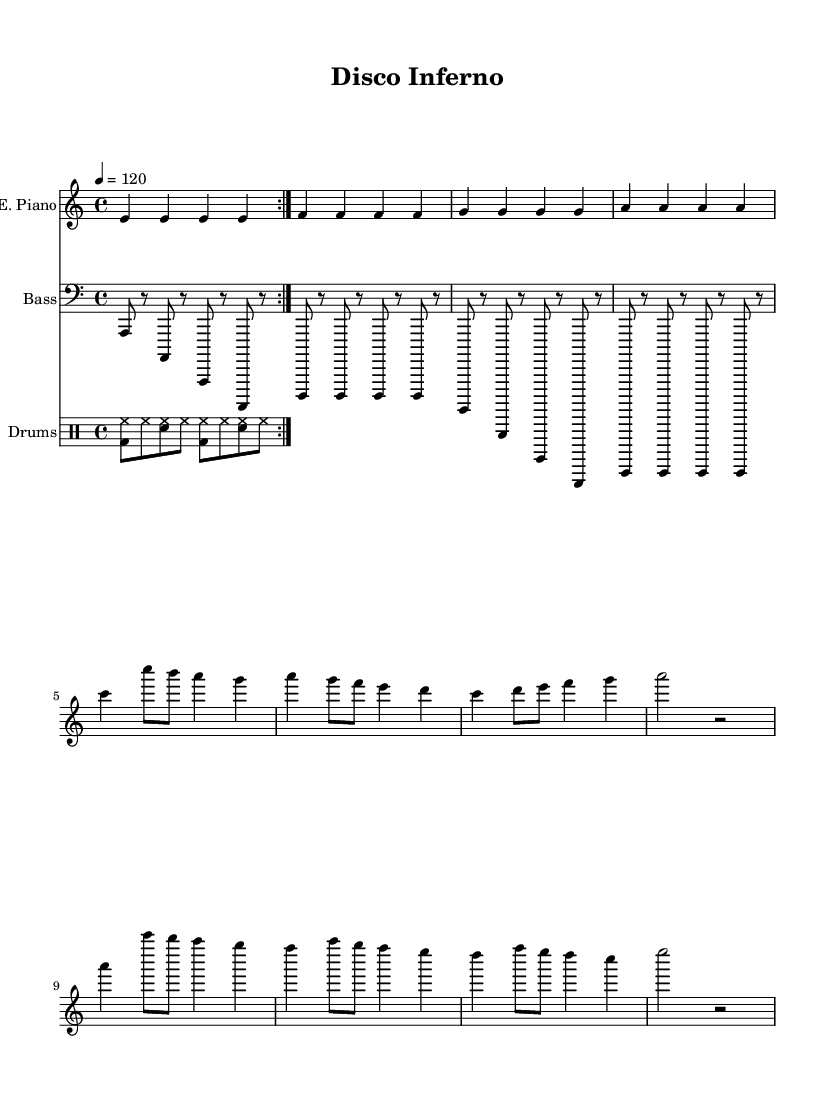What is the key signature of this music? The key signature is A minor, which has no sharps or flats. This can be determined by looking at the key signature indication at the beginning of the staff, which shows no accidentals.
Answer: A minor What is the time signature of this music? The time signature is 4/4, indicated by the two numbers at the beginning of the music. The top number '4' indicates four beats per measure, and the bottom number '4' indicates that a quarter note gets one beat.
Answer: 4/4 What is the tempo marking? The tempo marking is 120 beats per minute, shown at the start of the score. This indicates the speed of the music, specifically that there are 120 quarter note beats in one minute.
Answer: 120 How many measures are there in the electric piano part? The electric piano part contains 12 measures, which can be counted by identifying each vertical line that indicates the end of a measure.
Answer: 12 Which instrument has a clef marking for treble? The instrument with a clef marking for treble is the Electric Piano, as indicated by the treble clef at the beginning of its staff. This clef is used for higher-pitched instruments.
Answer: Electric Piano What is the unique characteristic of the bass guitar line in terms of rhythmic notation? The bass guitar line features eighth notes as its primary rhythmic values, which can be identified by the use of the '8' symbol next to the note values, indicating that each note has a duration of half a beat.
Answer: Eighth notes What rhythmic device is used in the drum pattern? The rhythmic device used in the drum pattern is a repeat sign, shown by a double bar line with dots, indicating that the section should be played two times. This creates a consistent groove typical in funk music.
Answer: Repeat sign 